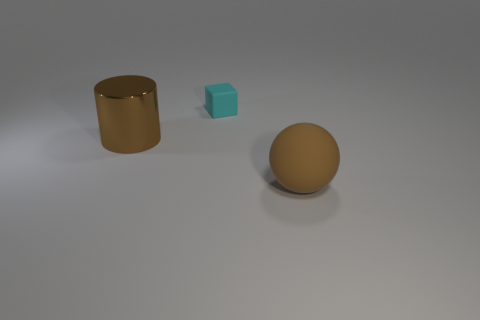The object that is made of the same material as the cyan block is what shape? sphere 